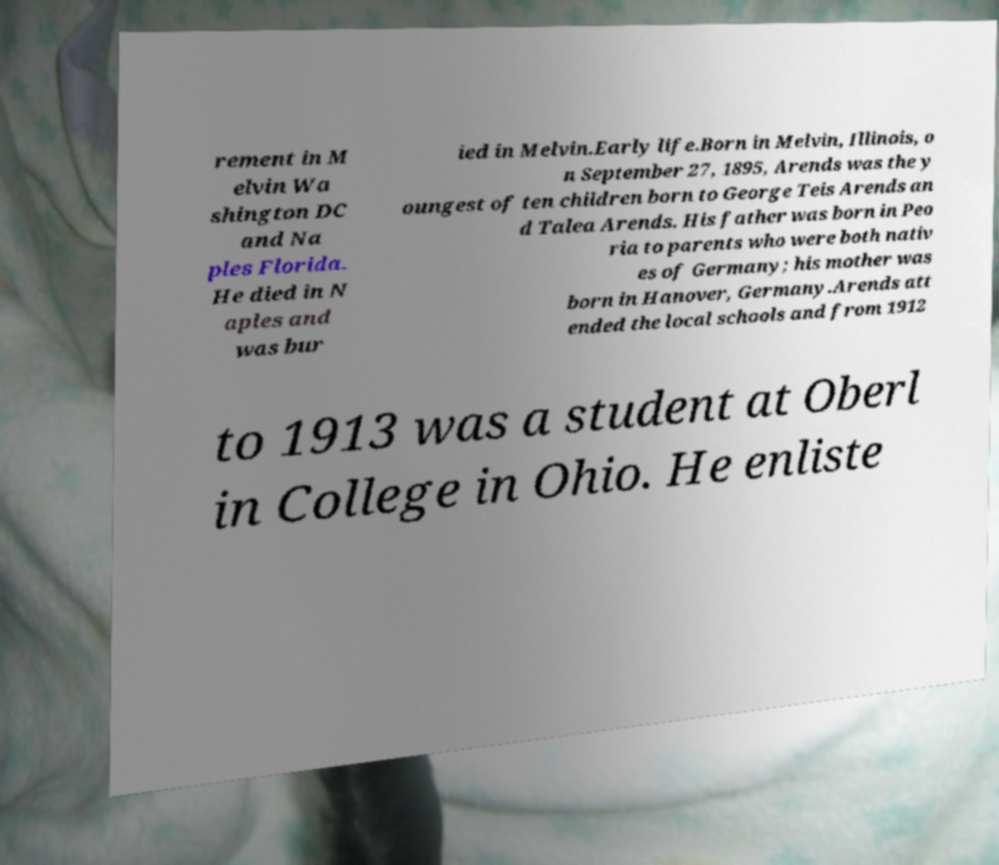Please identify and transcribe the text found in this image. rement in M elvin Wa shington DC and Na ples Florida. He died in N aples and was bur ied in Melvin.Early life.Born in Melvin, Illinois, o n September 27, 1895, Arends was the y oungest of ten children born to George Teis Arends an d Talea Arends. His father was born in Peo ria to parents who were both nativ es of Germany; his mother was born in Hanover, Germany.Arends att ended the local schools and from 1912 to 1913 was a student at Oberl in College in Ohio. He enliste 